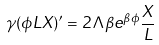Convert formula to latex. <formula><loc_0><loc_0><loc_500><loc_500>\gamma ( \phi L X ) ^ { \prime } = 2 \Lambda \beta e ^ { \beta \phi } \frac { X } { L }</formula> 